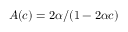Convert formula to latex. <formula><loc_0><loc_0><loc_500><loc_500>A ( c ) = 2 \alpha / ( 1 - 2 \alpha c )</formula> 